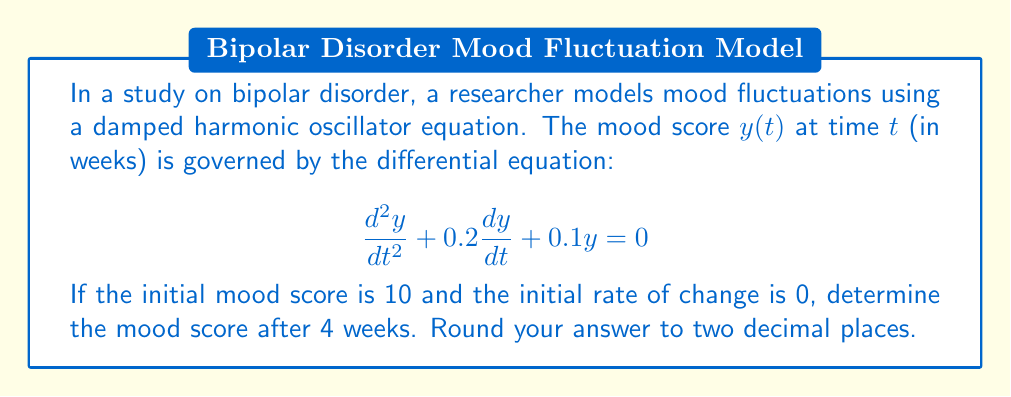Help me with this question. To solve this problem, we need to follow these steps:

1) The general solution for a damped harmonic oscillator equation of the form $\frac{d^2y}{dt^2} + 2\beta\frac{dy}{dt} + \omega_0^2y = 0$ is:

   $y(t) = e^{-\beta t}(A\cos(\omega t) + B\sin(\omega t))$

   where $\omega = \sqrt{\omega_0^2 - \beta^2}$

2) In our case, $2\beta = 0.2$, so $\beta = 0.1$, and $\omega_0^2 = 0.1$

3) Calculate $\omega$:
   $\omega = \sqrt{0.1 - 0.1^2} = \sqrt{0.09} = 0.3$

4) Our general solution is:
   $y(t) = e^{-0.1t}(A\cos(0.3t) + B\sin(0.3t))$

5) Use initial conditions to find A and B:
   At $t=0$, $y(0) = 10$, so $A = 10$
   At $t=0$, $y'(0) = 0$, so $-0.1A + 0.3B = 0$
   Solving this, we get $B = \frac{1}{3}A = \frac{10}{3}$

6) Our specific solution is:
   $y(t) = e^{-0.1t}(10\cos(0.3t) + \frac{10}{3}\sin(0.3t))$

7) Evaluate at $t=4$:
   $y(4) = e^{-0.4}(10\cos(1.2) + \frac{10}{3}\sin(1.2))$

8) Calculate this value:
   $y(4) \approx 5.24$
Answer: $5.24$ 